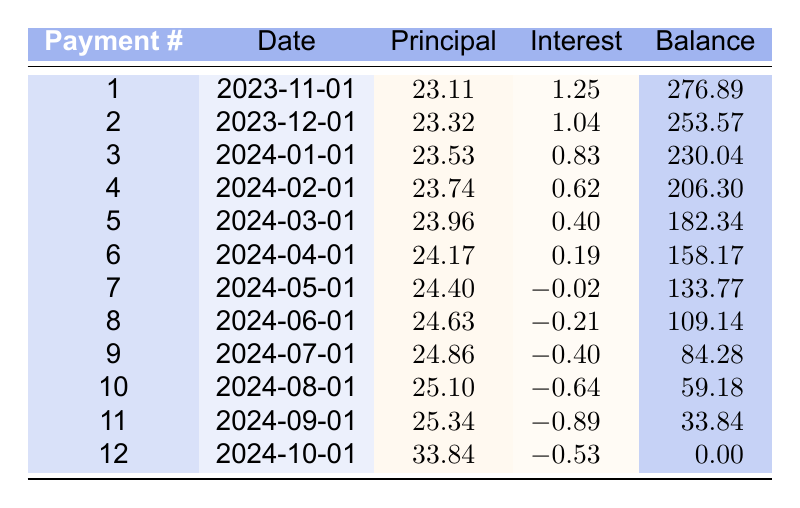What is the principal payment for the sixth payment? According to the table, the principal payment for the sixth payment (Payment #6) is found in the "Principal" column corresponding to the sixth row. The value listed there is 24.17.
Answer: 24.17 What is the total remaining balance after the third payment? The table shows the remaining balance after each payment. In the third row, which corresponds to the third payment, the remaining balance after the third payment (Payment #3) is 230.04.
Answer: 230.04 Is the interest payment for the seventh payment a positive number? The interest payment for Payment #7 can be checked in the "Interest" column of the seventh row. It is listed as -0.02, which indicates that it is not positive.
Answer: No What is the total amount of principal paid after the first four payments? To find the total principal paid after the first four payments, we sum the principal payments of Payments #1, #2, #3, and #4. The values are 23.11, 23.32, 23.53, and 23.74 respectively. Adding them up gives (23.11 + 23.32 + 23.53 + 23.74) = 93.70.
Answer: 93.70 What is the average interest payment across all 12 payments? To find the average interest payment, we first sum all the interest payments. From the table, the interest payments are: 1.25, 1.04, 0.83, 0.62, 0.40, 0.19, -0.02, -0.21, -0.40, -0.64, -0.89, and -0.53. The sum of these values is (1.25 + 1.04 + 0.83 + 0.62 + 0.40 + 0.19 - 0.02 - 0.21 - 0.40 - 0.64 - 0.89 - 0.53) = 1.03. Dividing this sum by 12 gives an average of approximately 0.086.
Answer: 0.086 What is the remaining balance after the tenth payment? The remaining balance after the tenth payment can be found in the "Balance" column corresponding to Payment #10. It shows 59.18 as the remaining balance.
Answer: 59.18 